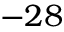Convert formula to latex. <formula><loc_0><loc_0><loc_500><loc_500>- 2 8</formula> 